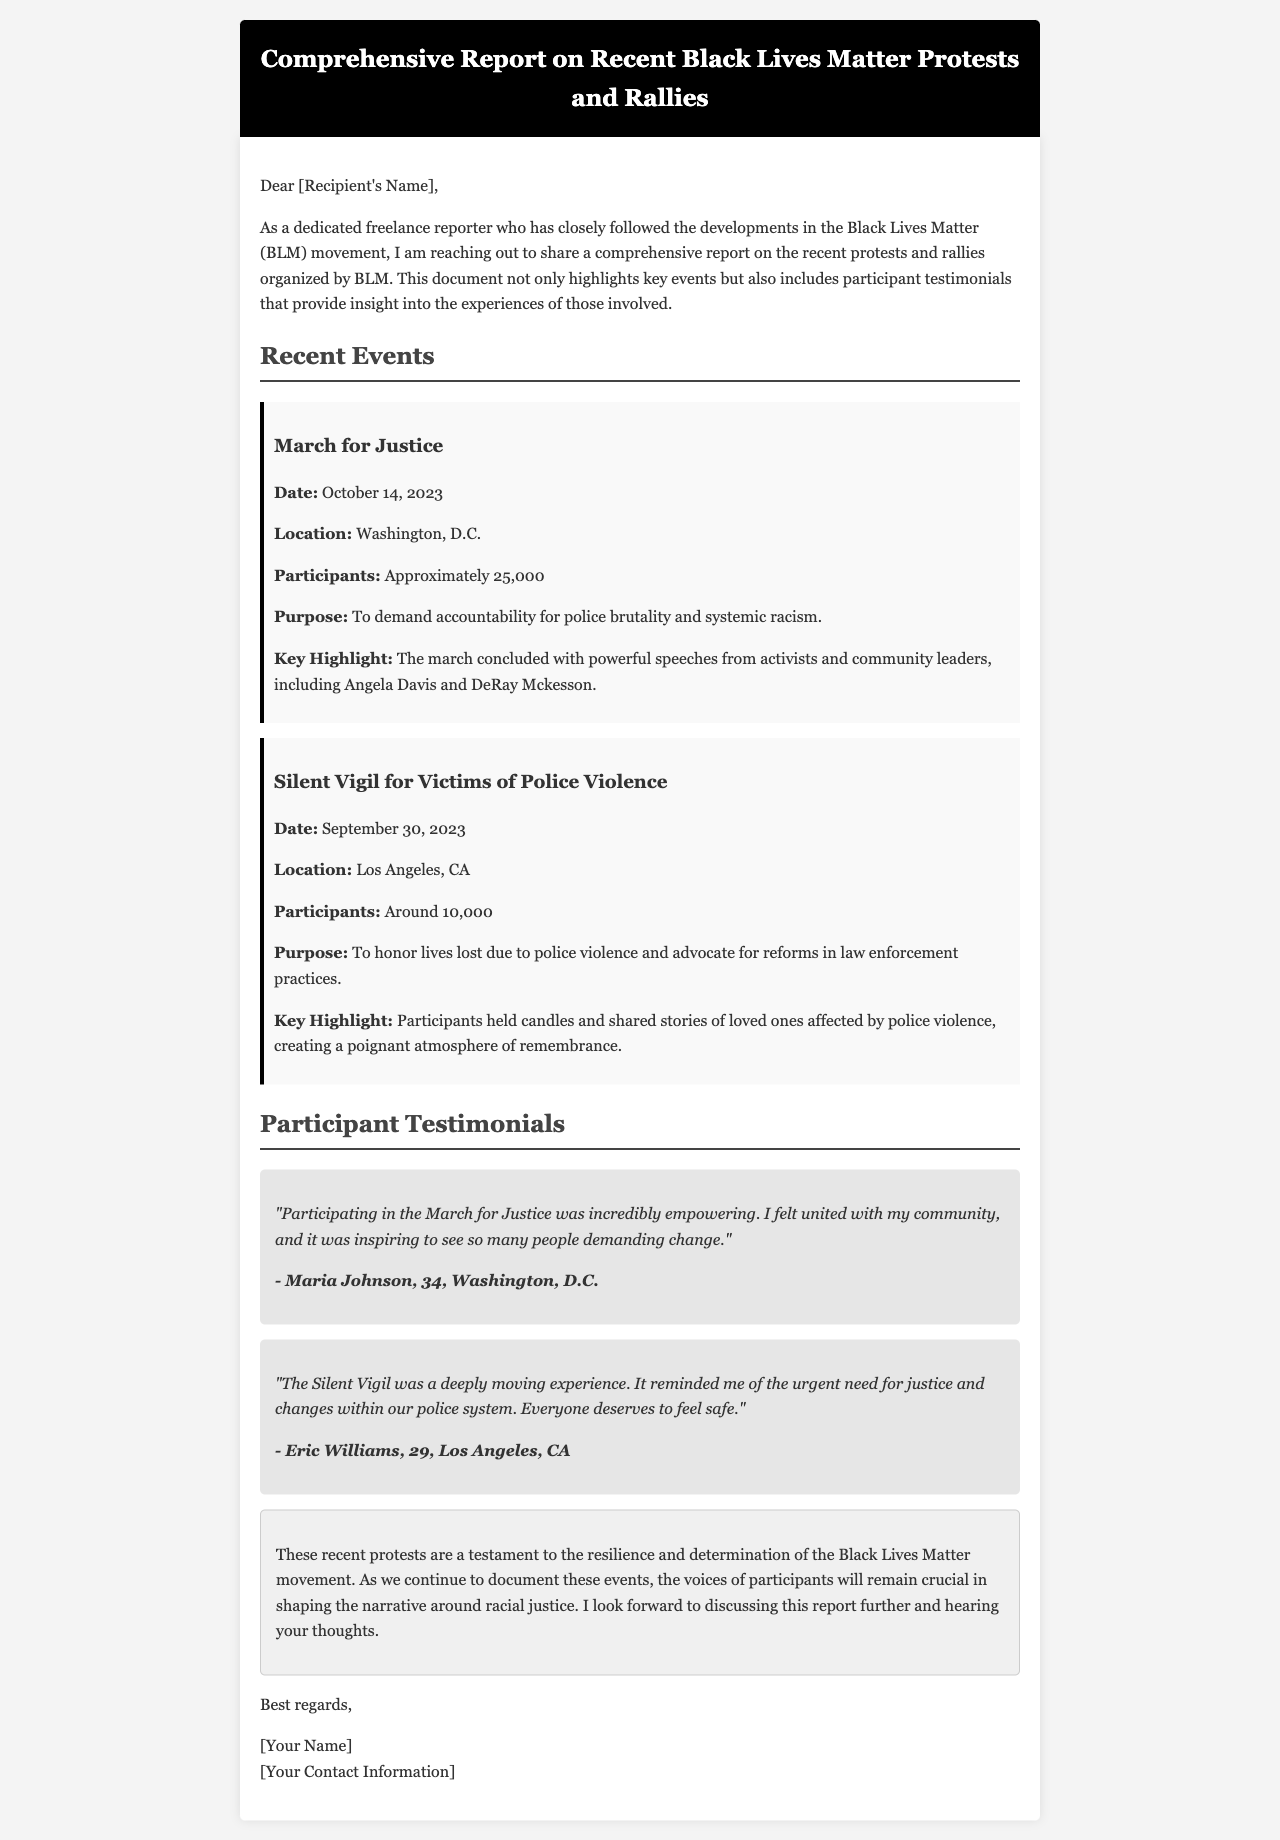What was the date of the March for Justice? The document states that the March for Justice took place on October 14, 2023.
Answer: October 14, 2023 How many participants attended the Silent Vigil for Victims of Police Violence? According to the report, approximately 10,000 participants attended the Silent Vigil.
Answer: Around 10,000 Who were the key speakers at the March for Justice? The report highlights that Angela Davis and DeRay Mckesson were key speakers at the event.
Answer: Angela Davis and DeRay Mckesson What was the purpose of the Silent Vigil? The document mentions that the purpose of the Silent Vigil was to honor lives lost due to police violence and advocate for reforms.
Answer: To honor lives lost due to police violence Which location hosted the March for Justice? The report indicates that the March for Justice was held in Washington, D.C.
Answer: Washington, D.C What did participants hold during the Silent Vigil? The document states that participants held candles during the Silent Vigil.
Answer: Candles What theme is reflected in the participant testimonials included in the report? The testimonials express empowerment and the urgent need for justice and change.
Answer: Empowerment and urgent need for justice What is the main conclusion drawn in the report? The document concludes that recent protests demonstrate resilience and determination within the Black Lives Matter movement.
Answer: Resilience and determination What type of document is this? The structure and content indicate that this is a comprehensive report in email format.
Answer: Comprehensive report in email format 